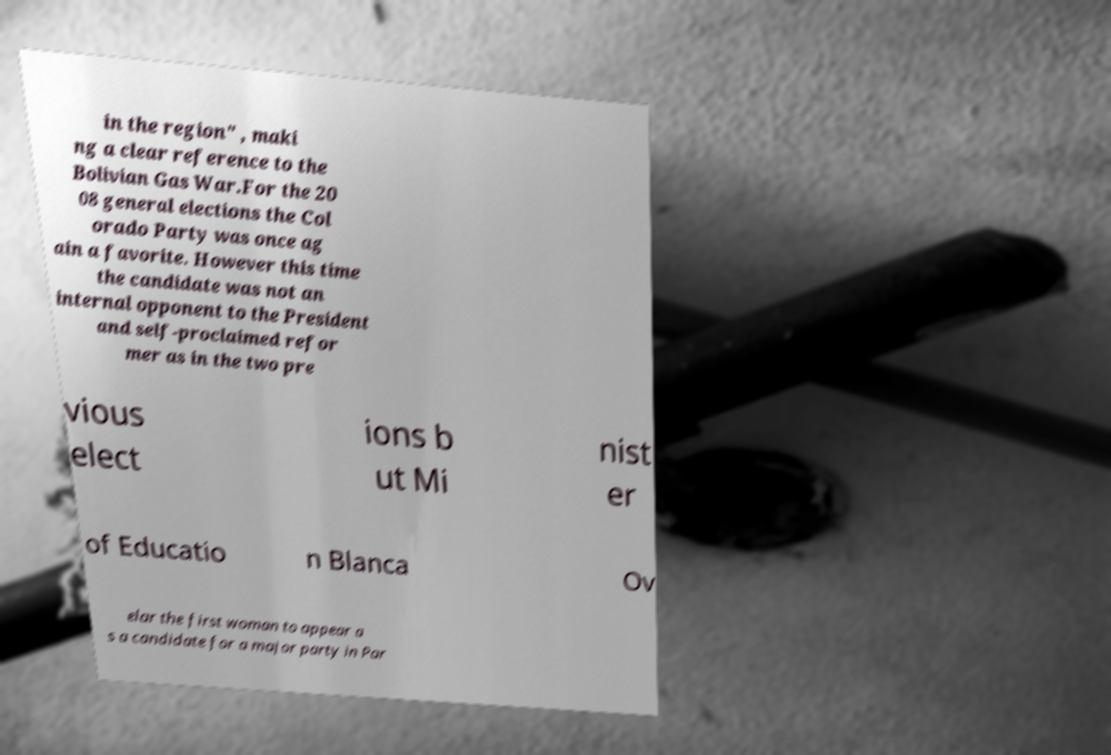What messages or text are displayed in this image? I need them in a readable, typed format. in the region" , maki ng a clear reference to the Bolivian Gas War.For the 20 08 general elections the Col orado Party was once ag ain a favorite. However this time the candidate was not an internal opponent to the President and self-proclaimed refor mer as in the two pre vious elect ions b ut Mi nist er of Educatio n Blanca Ov elar the first woman to appear a s a candidate for a major party in Par 